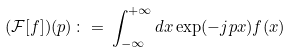Convert formula to latex. <formula><loc_0><loc_0><loc_500><loc_500>( { \mathcal { F } } [ f ] ) ( p ) \, \colon = \, \int _ { - \infty } ^ { + \infty } d x \exp ( - j p x ) f ( x )</formula> 